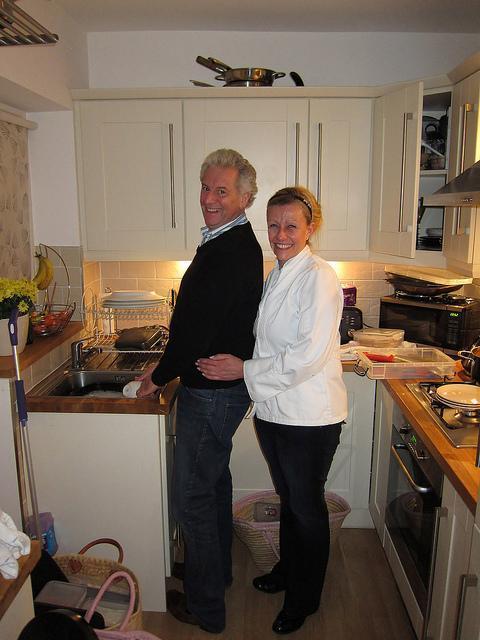How many people are there?
Give a very brief answer. 2. 